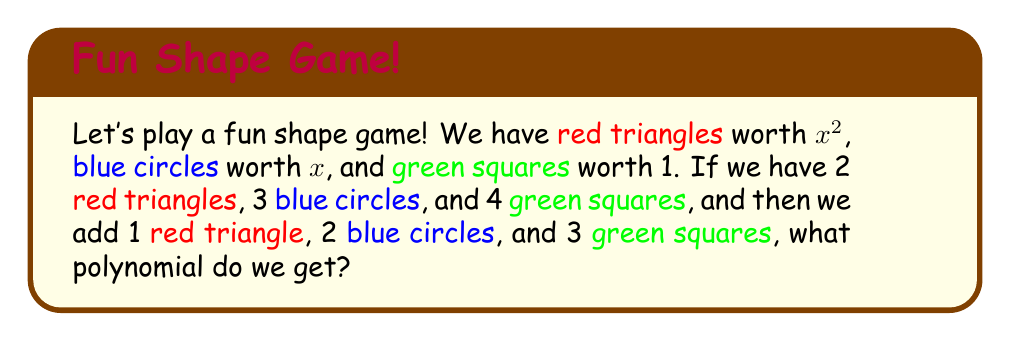Show me your answer to this math problem. Let's solve this step-by-step:

1. First, let's count what we have initially:
   - 2 red triangles (each worth $x^2$)
   - 3 blue circles (each worth $x$)
   - 4 green squares (each worth 1)

2. We can write this as a polynomial:
   $2x^2 + 3x + 4$

3. Now, let's count what we're adding:
   - 1 red triangle (worth $x^2$)
   - 2 blue circles (each worth $x$)
   - 3 green squares (each worth 1)

4. We can write this as another polynomial:
   $x^2 + 2x + 3$

5. To add these polynomials, we combine like terms:
   $(2x^2 + 3x + 4) + (x^2 + 2x + 3)$

6. Let's add the terms:
   - Red triangles (x^2 terms): $2x^2 + x^2 = 3x^2$
   - Blue circles (x terms): $3x + 2x = 5x$
   - Green squares (constant terms): $4 + 3 = 7$

7. Our final polynomial is:
   $3x^2 + 5x + 7$
Answer: $3x^2 + 5x + 7$ 